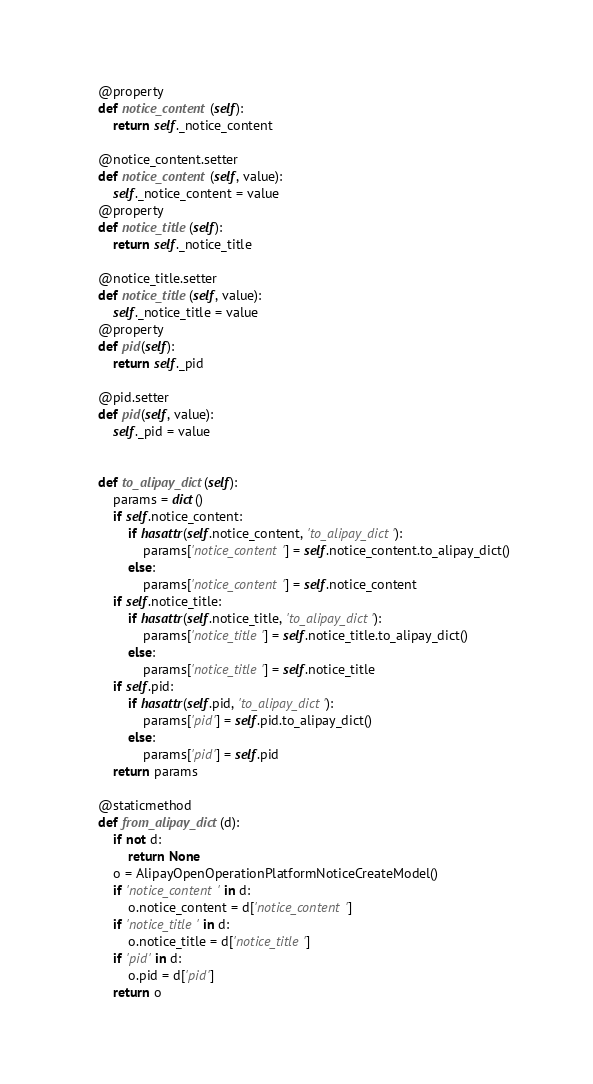<code> <loc_0><loc_0><loc_500><loc_500><_Python_>    @property
    def notice_content(self):
        return self._notice_content

    @notice_content.setter
    def notice_content(self, value):
        self._notice_content = value
    @property
    def notice_title(self):
        return self._notice_title

    @notice_title.setter
    def notice_title(self, value):
        self._notice_title = value
    @property
    def pid(self):
        return self._pid

    @pid.setter
    def pid(self, value):
        self._pid = value


    def to_alipay_dict(self):
        params = dict()
        if self.notice_content:
            if hasattr(self.notice_content, 'to_alipay_dict'):
                params['notice_content'] = self.notice_content.to_alipay_dict()
            else:
                params['notice_content'] = self.notice_content
        if self.notice_title:
            if hasattr(self.notice_title, 'to_alipay_dict'):
                params['notice_title'] = self.notice_title.to_alipay_dict()
            else:
                params['notice_title'] = self.notice_title
        if self.pid:
            if hasattr(self.pid, 'to_alipay_dict'):
                params['pid'] = self.pid.to_alipay_dict()
            else:
                params['pid'] = self.pid
        return params

    @staticmethod
    def from_alipay_dict(d):
        if not d:
            return None
        o = AlipayOpenOperationPlatformNoticeCreateModel()
        if 'notice_content' in d:
            o.notice_content = d['notice_content']
        if 'notice_title' in d:
            o.notice_title = d['notice_title']
        if 'pid' in d:
            o.pid = d['pid']
        return o


</code> 